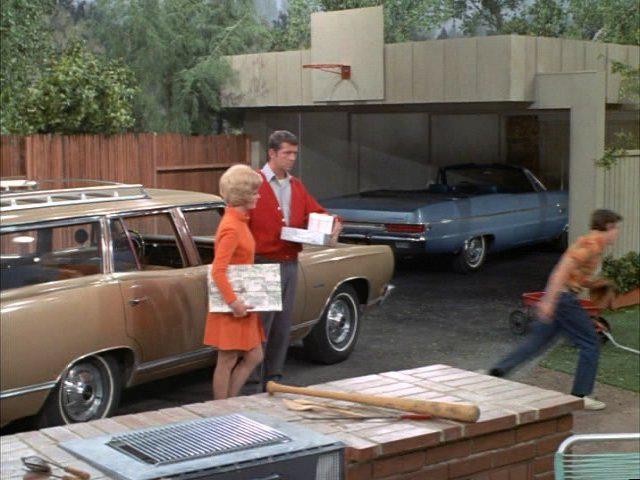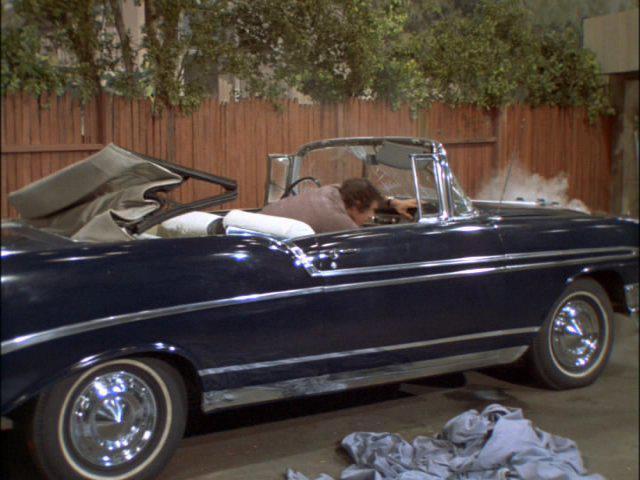The first image is the image on the left, the second image is the image on the right. Given the left and right images, does the statement "Neither of the cars has a hood or roof on it." hold true? Answer yes or no. No. The first image is the image on the left, the second image is the image on the right. Analyze the images presented: Is the assertion "An image shows a young man behind the wheel of a powder blue convertible with top down." valid? Answer yes or no. No. 